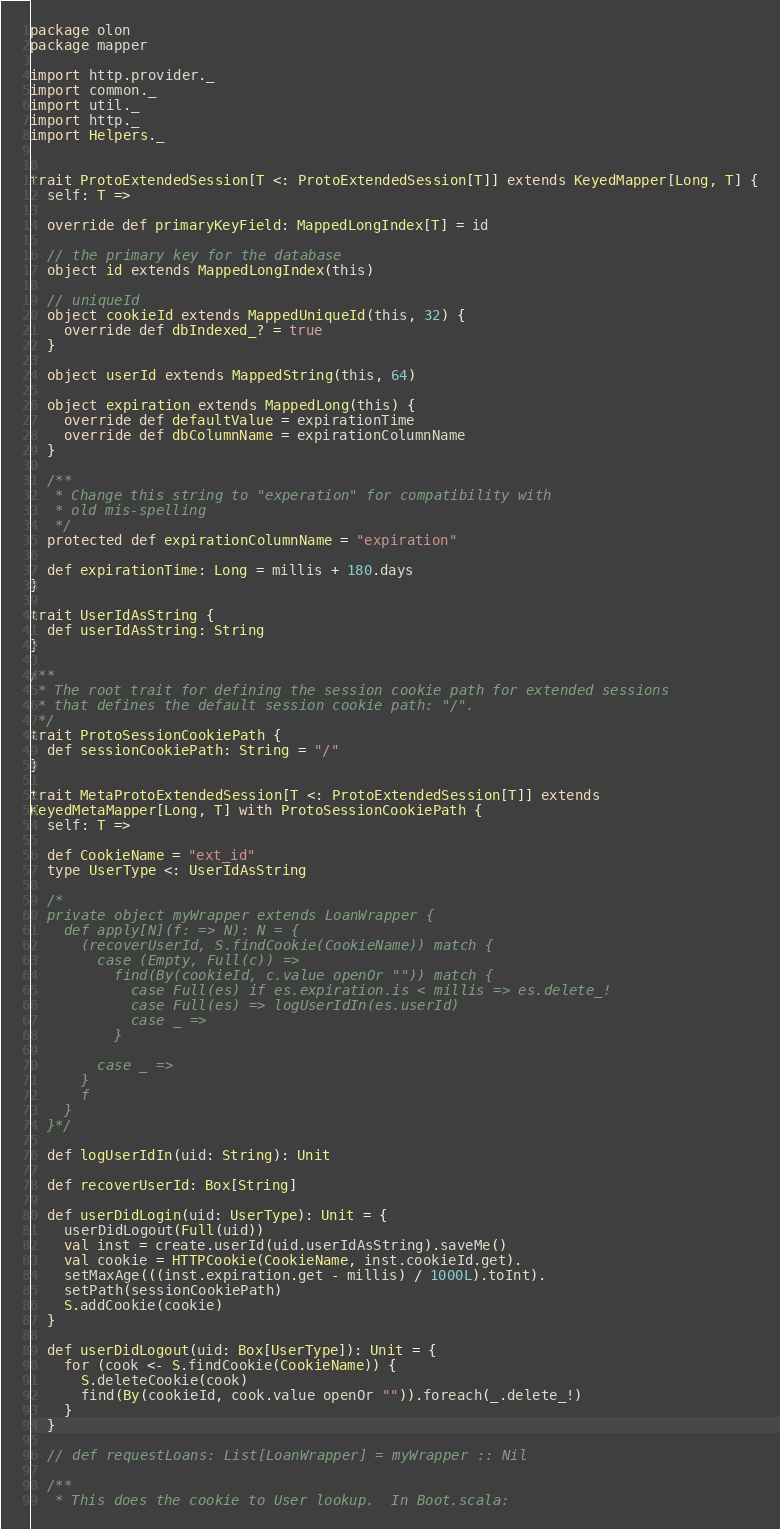<code> <loc_0><loc_0><loc_500><loc_500><_Scala_>package olon
package mapper

import http.provider._
import common._
import util._
import http._
import Helpers._


trait ProtoExtendedSession[T <: ProtoExtendedSession[T]] extends KeyedMapper[Long, T] {
  self: T =>

  override def primaryKeyField: MappedLongIndex[T] = id

  // the primary key for the database
  object id extends MappedLongIndex(this)

  // uniqueId
  object cookieId extends MappedUniqueId(this, 32) {
    override def dbIndexed_? = true
  }

  object userId extends MappedString(this, 64)

  object expiration extends MappedLong(this) {
    override def defaultValue = expirationTime
    override def dbColumnName = expirationColumnName
  }

  /**
   * Change this string to "experation" for compatibility with
   * old mis-spelling
   */
  protected def expirationColumnName = "expiration"

  def expirationTime: Long = millis + 180.days
}

trait UserIdAsString {
  def userIdAsString: String
}

/**
 * The root trait for defining the session cookie path for extended sessions
 * that defines the default session cookie path: "/".
 */
trait ProtoSessionCookiePath {
  def sessionCookiePath: String = "/"
}

trait MetaProtoExtendedSession[T <: ProtoExtendedSession[T]] extends
KeyedMetaMapper[Long, T] with ProtoSessionCookiePath {
  self: T =>

  def CookieName = "ext_id"
  type UserType <: UserIdAsString

  /*
  private object myWrapper extends LoanWrapper {
    def apply[N](f: => N): N = {
      (recoverUserId, S.findCookie(CookieName)) match {
        case (Empty, Full(c)) =>
          find(By(cookieId, c.value openOr "")) match {
            case Full(es) if es.expiration.is < millis => es.delete_!
            case Full(es) => logUserIdIn(es.userId)
            case _ =>
          }

        case _ =>
      }
      f
    }
  }*/

  def logUserIdIn(uid: String): Unit

  def recoverUserId: Box[String]

  def userDidLogin(uid: UserType): Unit = {
    userDidLogout(Full(uid))
    val inst = create.userId(uid.userIdAsString).saveMe()
    val cookie = HTTPCookie(CookieName, inst.cookieId.get).
    setMaxAge(((inst.expiration.get - millis) / 1000L).toInt).
    setPath(sessionCookiePath)
    S.addCookie(cookie)
  }

  def userDidLogout(uid: Box[UserType]): Unit = {
    for (cook <- S.findCookie(CookieName)) {
      S.deleteCookie(cook)
      find(By(cookieId, cook.value openOr "")).foreach(_.delete_!)
    }
  }

  // def requestLoans: List[LoanWrapper] = myWrapper :: Nil

  /**
   * This does the cookie to User lookup.  In Boot.scala:</code> 